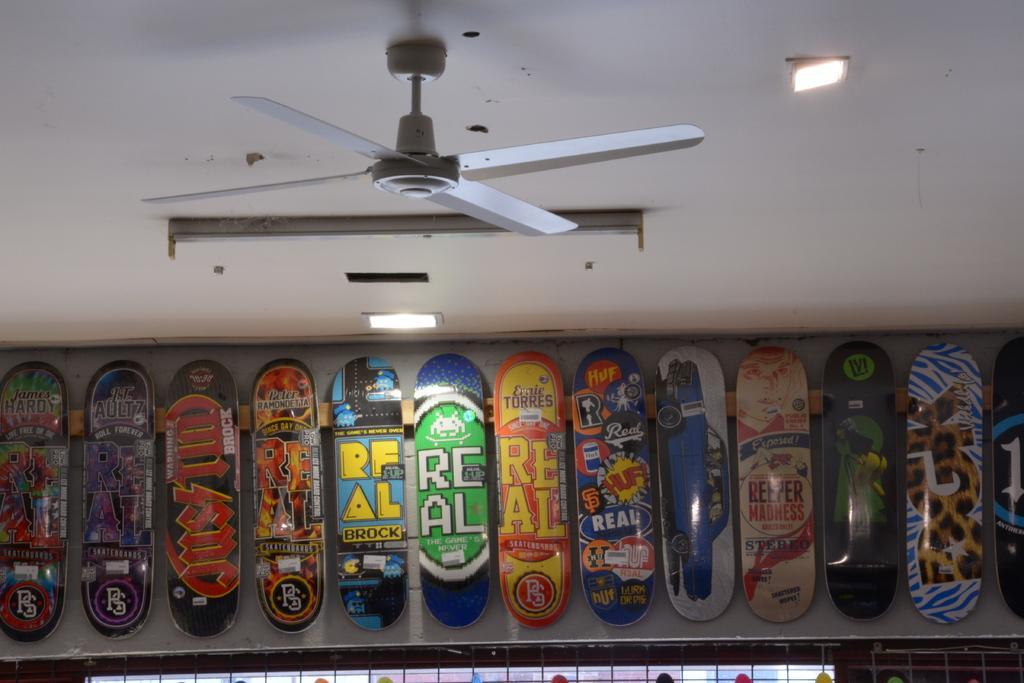Could you give a brief overview of what you see in this image? This picture seems to be clicked inside the room. In the foreground we can see the skateboards seems to be hanging on the wall and we can see the text and some pictures on the skateboards. At the top there is a roof, ceiling lights, ceiling fan and some other objects. 